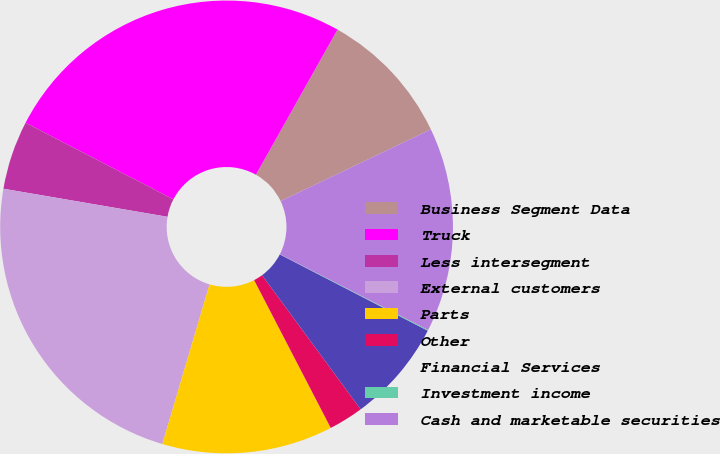Convert chart. <chart><loc_0><loc_0><loc_500><loc_500><pie_chart><fcel>Business Segment Data<fcel>Truck<fcel>Less intersegment<fcel>External customers<fcel>Parts<fcel>Other<fcel>Financial Services<fcel>Investment income<fcel>Cash and marketable securities<nl><fcel>9.76%<fcel>25.54%<fcel>4.91%<fcel>23.12%<fcel>12.19%<fcel>2.48%<fcel>7.33%<fcel>0.06%<fcel>14.61%<nl></chart> 